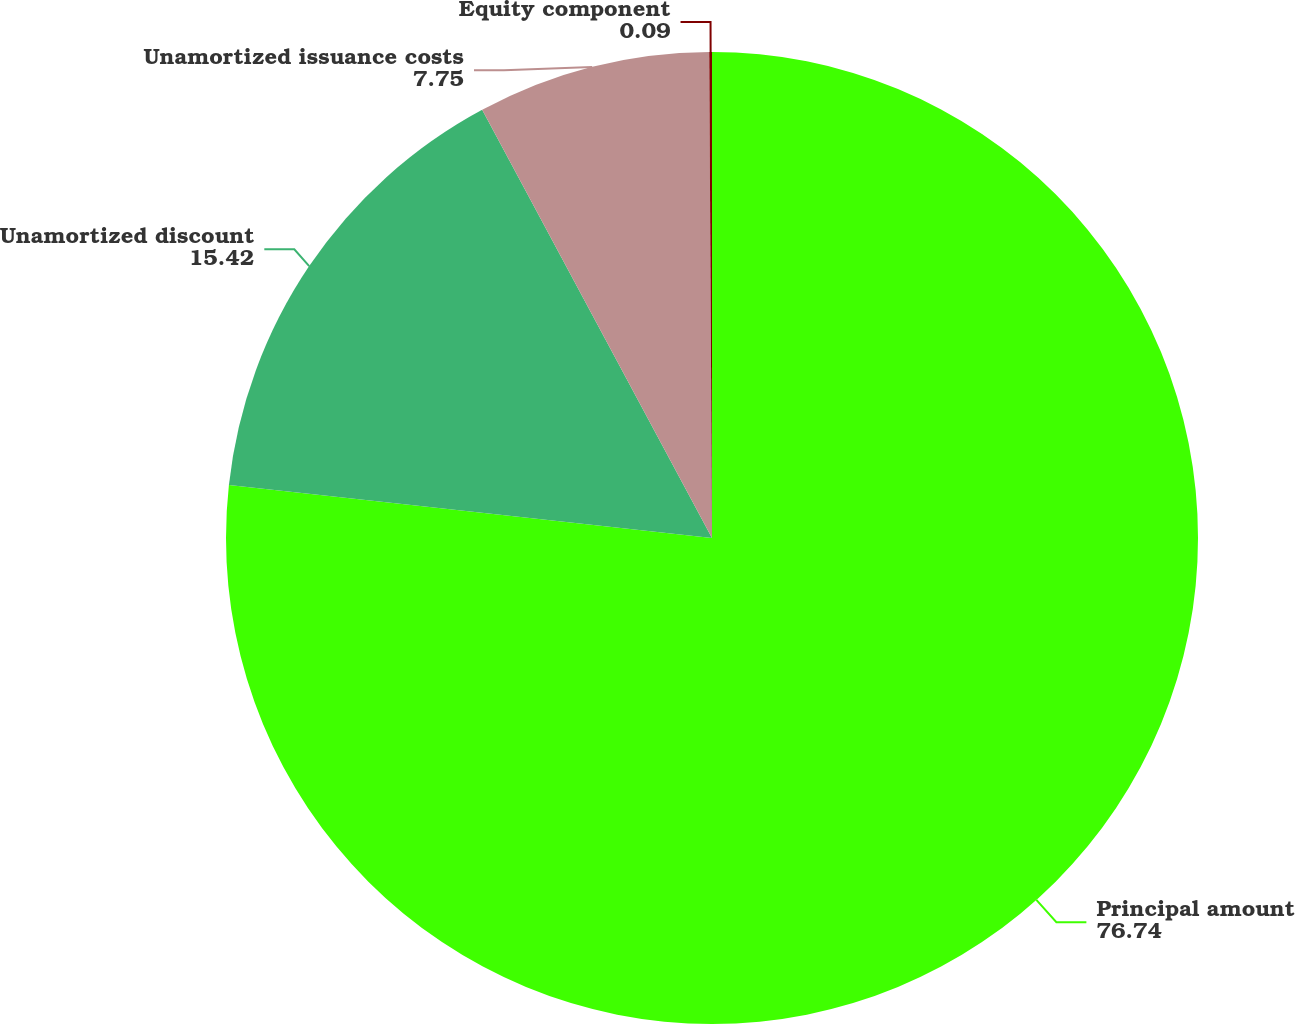Convert chart to OTSL. <chart><loc_0><loc_0><loc_500><loc_500><pie_chart><fcel>Principal amount<fcel>Unamortized discount<fcel>Unamortized issuance costs<fcel>Equity component<nl><fcel>76.74%<fcel>15.42%<fcel>7.75%<fcel>0.09%<nl></chart> 